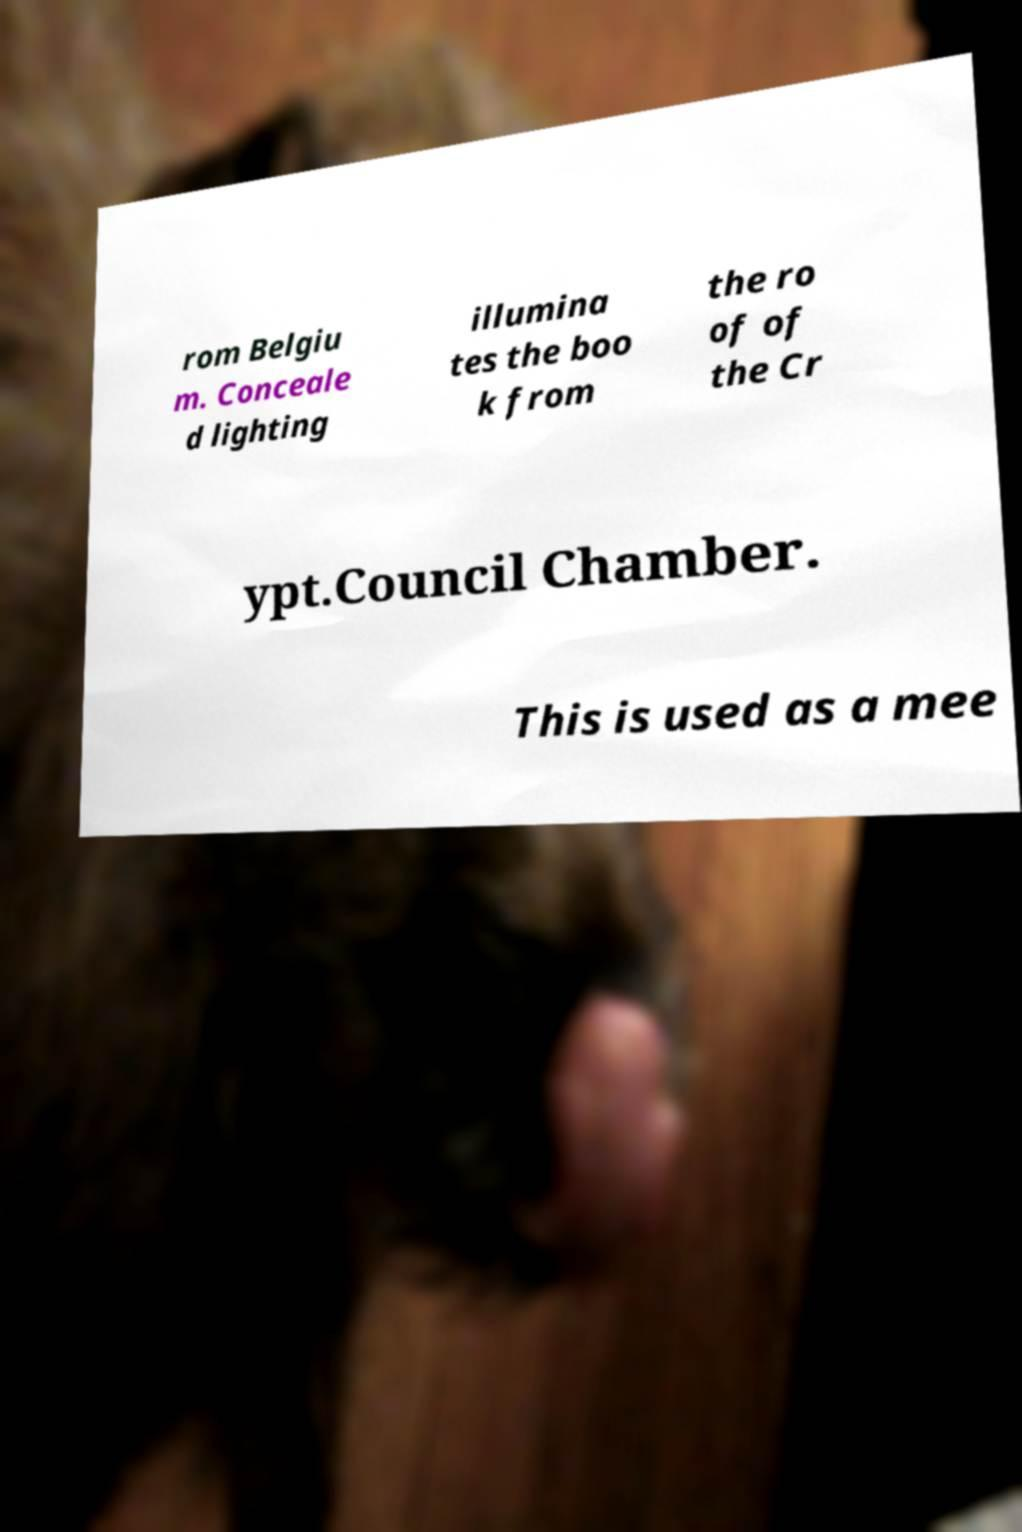There's text embedded in this image that I need extracted. Can you transcribe it verbatim? rom Belgiu m. Conceale d lighting illumina tes the boo k from the ro of of the Cr ypt.Council Chamber. This is used as a mee 